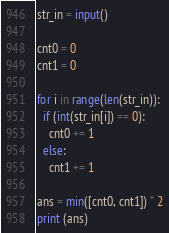<code> <loc_0><loc_0><loc_500><loc_500><_Python_>str_in = input()

cnt0 = 0
cnt1 = 0

for i in range(len(str_in)):
  if (int(str_in[i]) == 0):
    cnt0 += 1
  else:
    cnt1 += 1

ans = min([cnt0, cnt1]) * 2
print (ans)</code> 